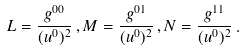Convert formula to latex. <formula><loc_0><loc_0><loc_500><loc_500>L = \frac { g ^ { 0 0 } } { ( u ^ { 0 } ) ^ { 2 } } \, , M = \frac { g ^ { 0 1 } } { ( u ^ { 0 } ) ^ { 2 } } \, , N = \frac { g ^ { 1 1 } } { ( u ^ { 0 } ) ^ { 2 } } \, .</formula> 